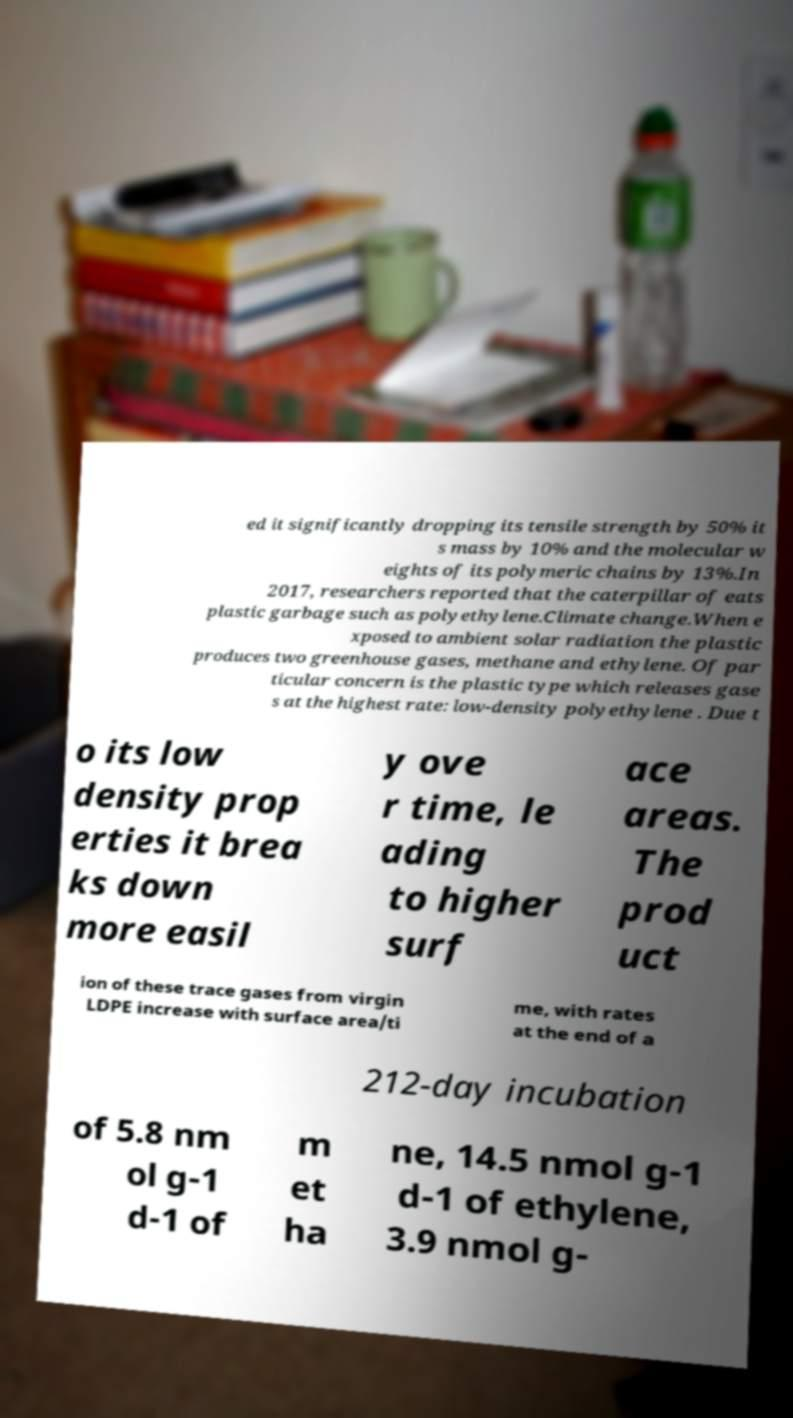Could you extract and type out the text from this image? ed it significantly dropping its tensile strength by 50% it s mass by 10% and the molecular w eights of its polymeric chains by 13%.In 2017, researchers reported that the caterpillar of eats plastic garbage such as polyethylene.Climate change.When e xposed to ambient solar radiation the plastic produces two greenhouse gases, methane and ethylene. Of par ticular concern is the plastic type which releases gase s at the highest rate: low-density polyethylene . Due t o its low density prop erties it brea ks down more easil y ove r time, le ading to higher surf ace areas. The prod uct ion of these trace gases from virgin LDPE increase with surface area/ti me, with rates at the end of a 212-day incubation of 5.8 nm ol g-1 d-1 of m et ha ne, 14.5 nmol g-1 d-1 of ethylene, 3.9 nmol g- 